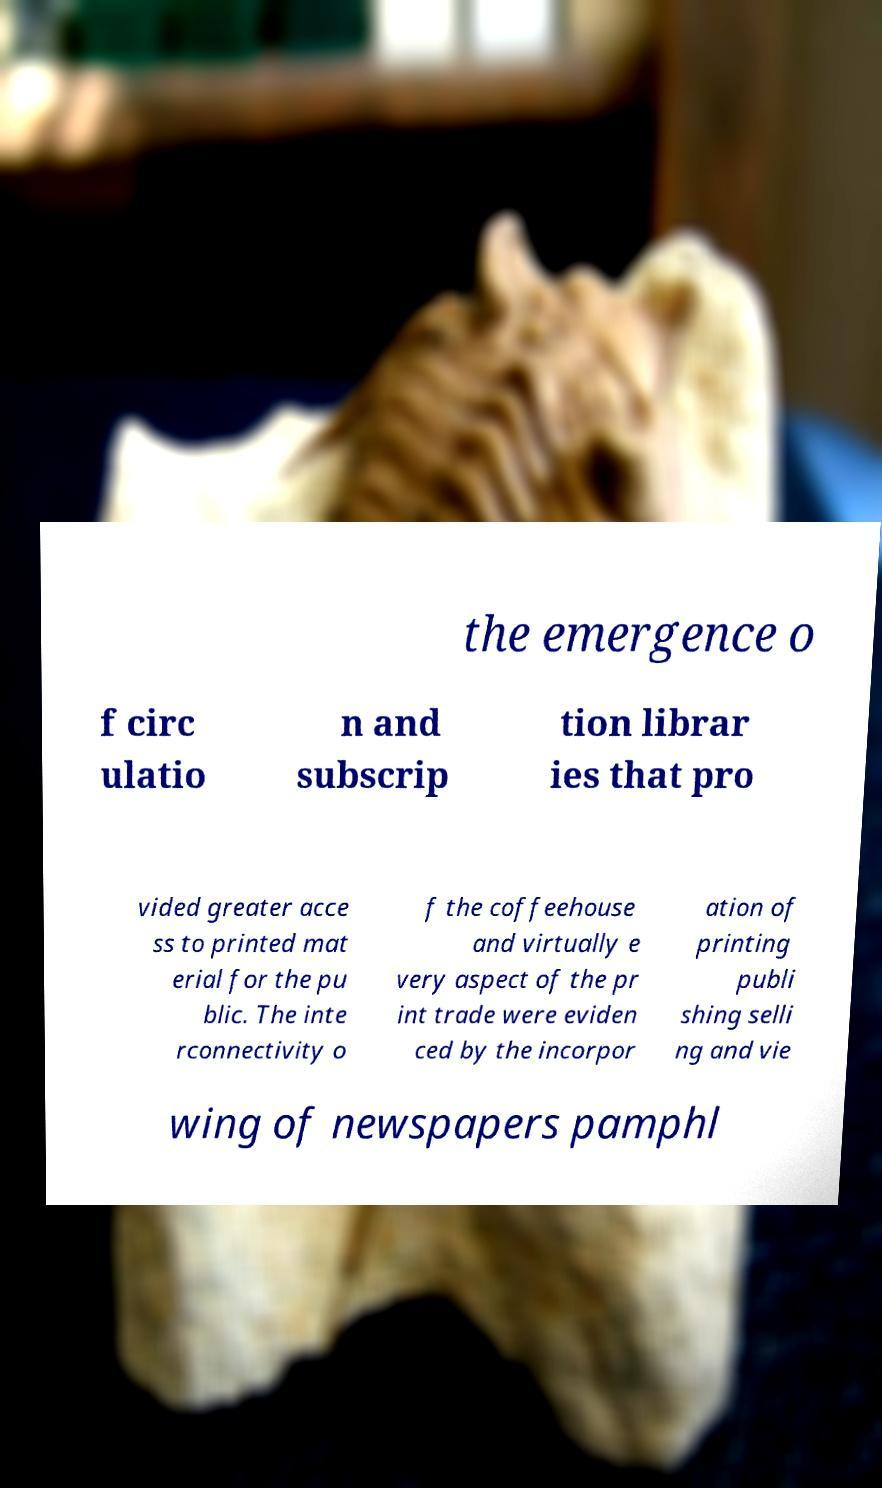Can you read and provide the text displayed in the image?This photo seems to have some interesting text. Can you extract and type it out for me? the emergence o f circ ulatio n and subscrip tion librar ies that pro vided greater acce ss to printed mat erial for the pu blic. The inte rconnectivity o f the coffeehouse and virtually e very aspect of the pr int trade were eviden ced by the incorpor ation of printing publi shing selli ng and vie wing of newspapers pamphl 